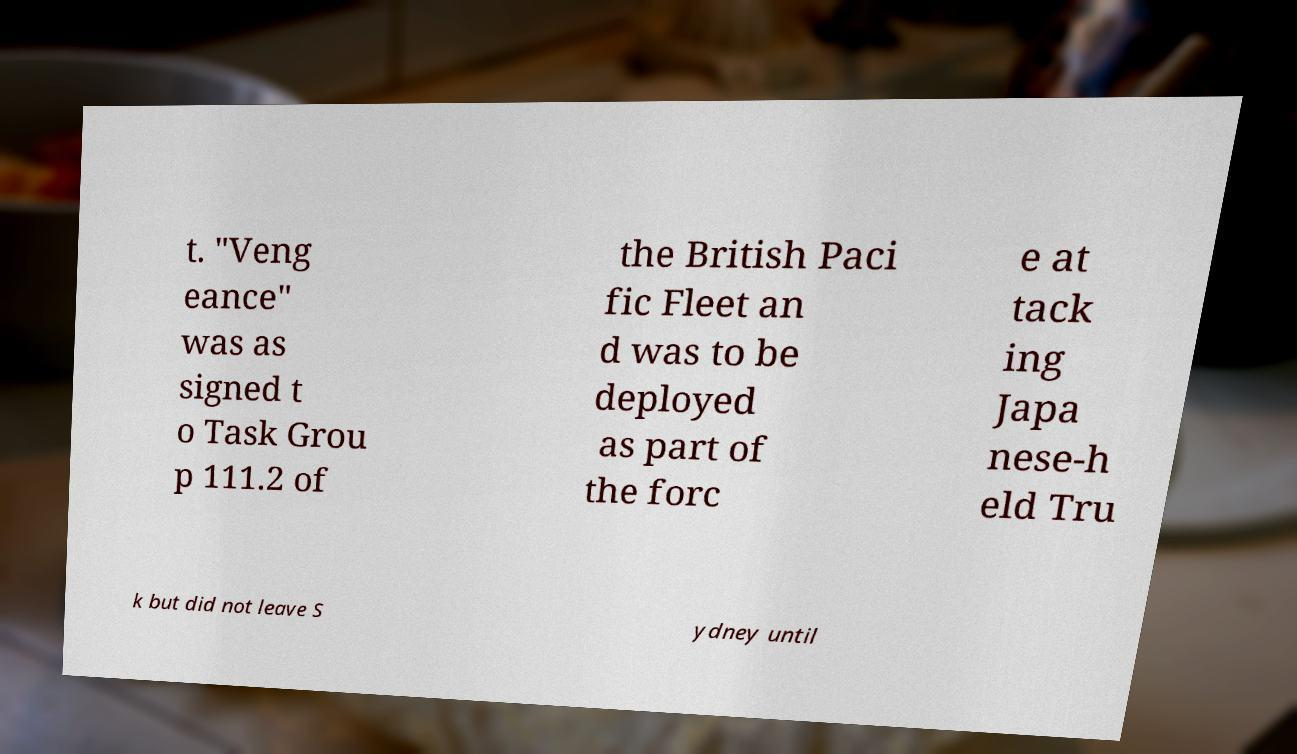Please identify and transcribe the text found in this image. t. "Veng eance" was as signed t o Task Grou p 111.2 of the British Paci fic Fleet an d was to be deployed as part of the forc e at tack ing Japa nese-h eld Tru k but did not leave S ydney until 